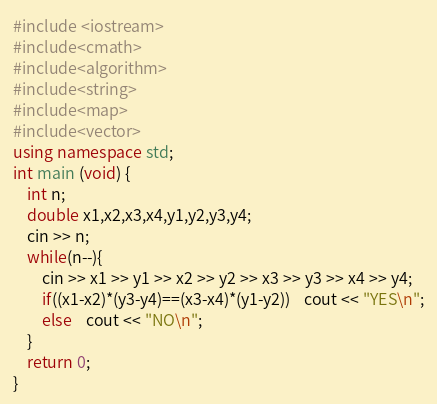Convert code to text. <code><loc_0><loc_0><loc_500><loc_500><_C++_>#include <iostream>
#include<cmath>
#include<algorithm>
#include<string>
#include<map>
#include<vector>
using namespace std;
int main (void) {
    int n;
    double x1,x2,x3,x4,y1,y2,y3,y4;
    cin >> n;
    while(n--){
        cin >> x1 >> y1 >> x2 >> y2 >> x3 >> y3 >> x4 >> y4;
        if((x1-x2)*(y3-y4)==(x3-x4)*(y1-y2))    cout << "YES\n";
        else    cout << "NO\n";
    }
    return 0;
}

</code> 